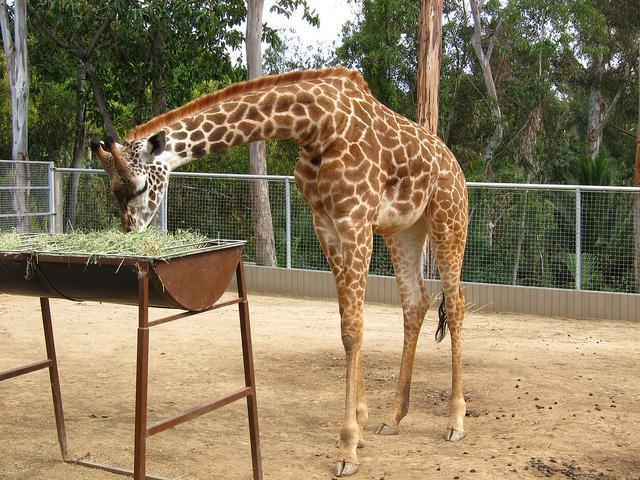How many horns can you see?
Give a very brief answer. 2. How many zoo creatures?
Give a very brief answer. 1. 